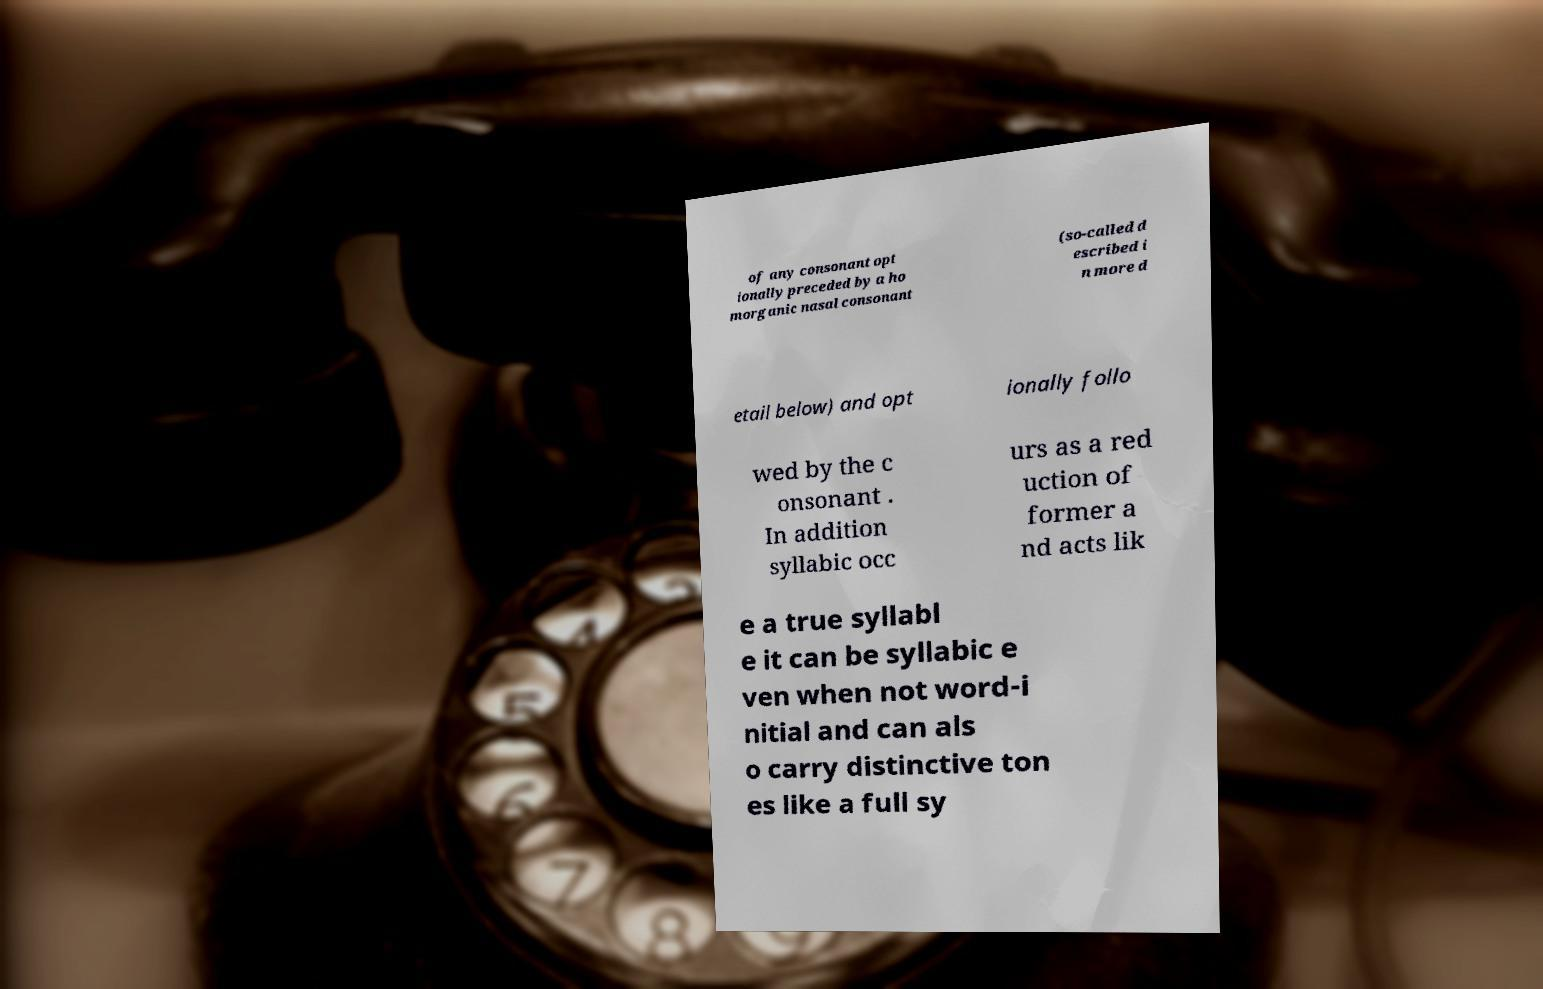Could you assist in decoding the text presented in this image and type it out clearly? of any consonant opt ionally preceded by a ho morganic nasal consonant (so-called d escribed i n more d etail below) and opt ionally follo wed by the c onsonant . In addition syllabic occ urs as a red uction of former a nd acts lik e a true syllabl e it can be syllabic e ven when not word-i nitial and can als o carry distinctive ton es like a full sy 